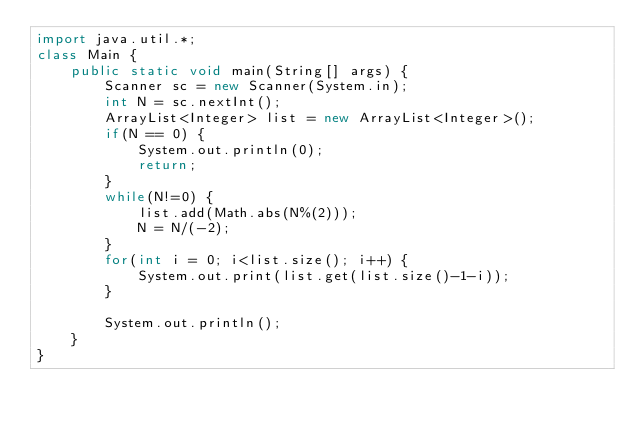<code> <loc_0><loc_0><loc_500><loc_500><_Java_>import java.util.*;
class Main {
    public static void main(String[] args) {
        Scanner sc = new Scanner(System.in);
        int N = sc.nextInt();
        ArrayList<Integer> list = new ArrayList<Integer>();
        if(N == 0) {
            System.out.println(0);
            return;
        }
        while(N!=0) {
            list.add(Math.abs(N%(2)));
            N = N/(-2);
        }
        for(int i = 0; i<list.size(); i++) {
            System.out.print(list.get(list.size()-1-i));
        }

        System.out.println();
    }
}</code> 